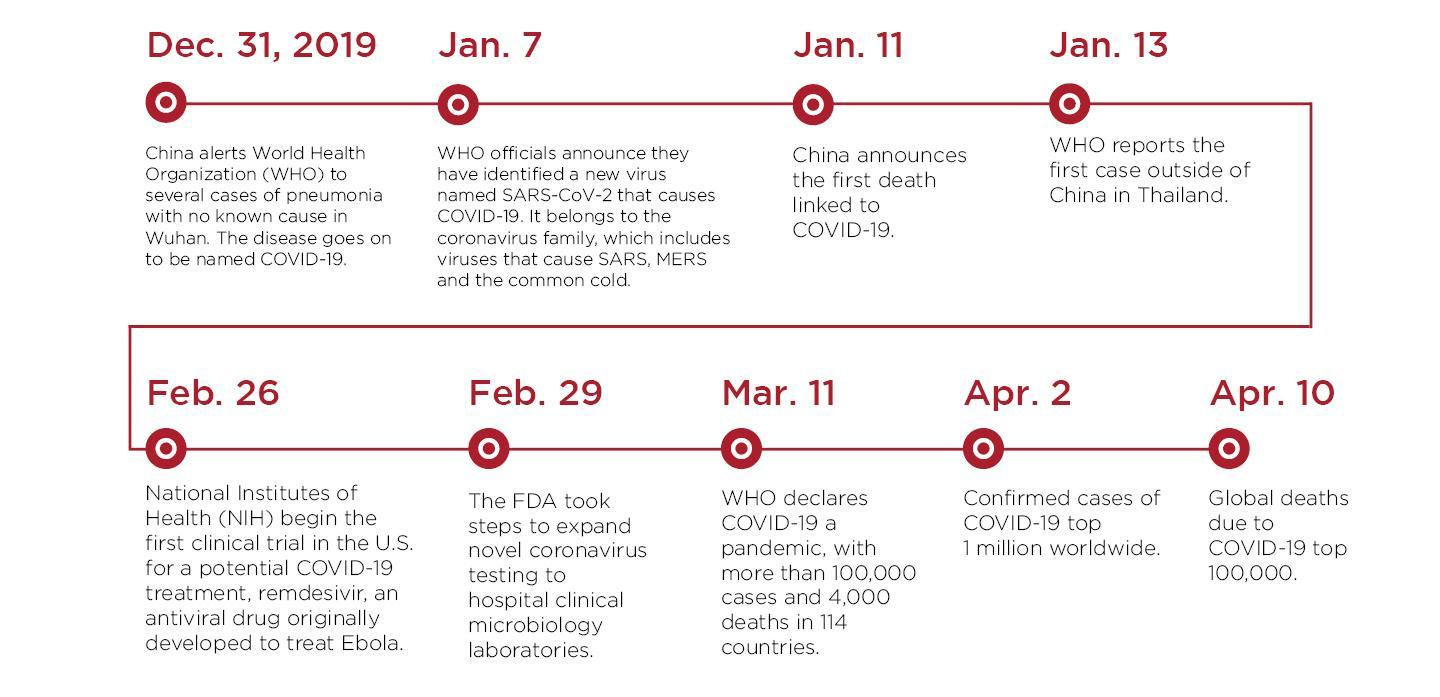When was the first death linked to covid-19 reported?
Answer the question with a short phrase. Jan. 11 When did the number of cases cross 1 million worldwide? Apr. 2 When did WHO report the first case outside china? Jan. 13 